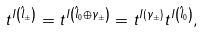<formula> <loc_0><loc_0><loc_500><loc_500>t ^ { I \left ( \hat { l } _ { \pm } \right ) } = t ^ { I \left ( \hat { l } _ { 0 } \oplus \gamma _ { \pm } \right ) } = t ^ { I \left ( \gamma _ { \pm } \right ) } t ^ { I \left ( \hat { l } _ { 0 } \right ) } ,</formula> 